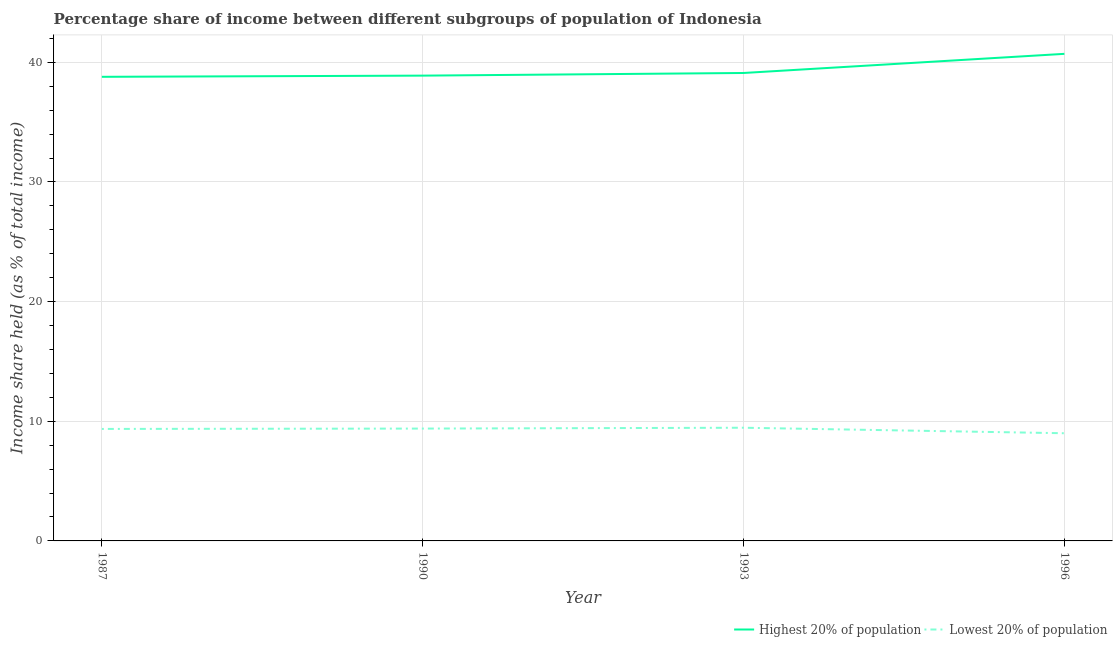How many different coloured lines are there?
Offer a terse response. 2. Does the line corresponding to income share held by lowest 20% of the population intersect with the line corresponding to income share held by highest 20% of the population?
Keep it short and to the point. No. Is the number of lines equal to the number of legend labels?
Your answer should be very brief. Yes. What is the income share held by highest 20% of the population in 1987?
Provide a short and direct response. 38.79. Across all years, what is the maximum income share held by highest 20% of the population?
Provide a succinct answer. 40.71. Across all years, what is the minimum income share held by highest 20% of the population?
Your response must be concise. 38.79. In which year was the income share held by lowest 20% of the population minimum?
Your answer should be very brief. 1996. What is the total income share held by lowest 20% of the population in the graph?
Your answer should be compact. 37.21. What is the difference between the income share held by lowest 20% of the population in 1987 and that in 1990?
Ensure brevity in your answer.  -0.03. What is the difference between the income share held by highest 20% of the population in 1996 and the income share held by lowest 20% of the population in 1990?
Ensure brevity in your answer.  31.32. What is the average income share held by highest 20% of the population per year?
Provide a short and direct response. 39.38. In the year 1993, what is the difference between the income share held by lowest 20% of the population and income share held by highest 20% of the population?
Offer a terse response. -29.65. What is the ratio of the income share held by highest 20% of the population in 1987 to that in 1996?
Provide a succinct answer. 0.95. Is the income share held by highest 20% of the population in 1990 less than that in 1993?
Provide a succinct answer. Yes. Is the difference between the income share held by lowest 20% of the population in 1987 and 1996 greater than the difference between the income share held by highest 20% of the population in 1987 and 1996?
Your answer should be compact. Yes. What is the difference between the highest and the second highest income share held by lowest 20% of the population?
Your answer should be very brief. 0.07. What is the difference between the highest and the lowest income share held by lowest 20% of the population?
Your answer should be compact. 0.46. In how many years, is the income share held by lowest 20% of the population greater than the average income share held by lowest 20% of the population taken over all years?
Ensure brevity in your answer.  3. Is the income share held by highest 20% of the population strictly less than the income share held by lowest 20% of the population over the years?
Make the answer very short. No. How many lines are there?
Your response must be concise. 2. How many years are there in the graph?
Offer a very short reply. 4. Are the values on the major ticks of Y-axis written in scientific E-notation?
Make the answer very short. No. Does the graph contain any zero values?
Offer a very short reply. No. Where does the legend appear in the graph?
Ensure brevity in your answer.  Bottom right. What is the title of the graph?
Provide a short and direct response. Percentage share of income between different subgroups of population of Indonesia. Does "Investment" appear as one of the legend labels in the graph?
Provide a succinct answer. No. What is the label or title of the X-axis?
Keep it short and to the point. Year. What is the label or title of the Y-axis?
Your answer should be very brief. Income share held (as % of total income). What is the Income share held (as % of total income) of Highest 20% of population in 1987?
Your answer should be compact. 38.79. What is the Income share held (as % of total income) in Lowest 20% of population in 1987?
Offer a very short reply. 9.36. What is the Income share held (as % of total income) of Highest 20% of population in 1990?
Your answer should be very brief. 38.89. What is the Income share held (as % of total income) of Lowest 20% of population in 1990?
Offer a very short reply. 9.39. What is the Income share held (as % of total income) of Highest 20% of population in 1993?
Provide a succinct answer. 39.11. What is the Income share held (as % of total income) in Lowest 20% of population in 1993?
Offer a terse response. 9.46. What is the Income share held (as % of total income) in Highest 20% of population in 1996?
Provide a succinct answer. 40.71. Across all years, what is the maximum Income share held (as % of total income) of Highest 20% of population?
Your answer should be compact. 40.71. Across all years, what is the maximum Income share held (as % of total income) in Lowest 20% of population?
Provide a short and direct response. 9.46. Across all years, what is the minimum Income share held (as % of total income) in Highest 20% of population?
Your answer should be very brief. 38.79. What is the total Income share held (as % of total income) in Highest 20% of population in the graph?
Make the answer very short. 157.5. What is the total Income share held (as % of total income) of Lowest 20% of population in the graph?
Offer a very short reply. 37.21. What is the difference between the Income share held (as % of total income) of Highest 20% of population in 1987 and that in 1990?
Keep it short and to the point. -0.1. What is the difference between the Income share held (as % of total income) of Lowest 20% of population in 1987 and that in 1990?
Make the answer very short. -0.03. What is the difference between the Income share held (as % of total income) of Highest 20% of population in 1987 and that in 1993?
Provide a short and direct response. -0.32. What is the difference between the Income share held (as % of total income) in Lowest 20% of population in 1987 and that in 1993?
Give a very brief answer. -0.1. What is the difference between the Income share held (as % of total income) of Highest 20% of population in 1987 and that in 1996?
Offer a terse response. -1.92. What is the difference between the Income share held (as % of total income) of Lowest 20% of population in 1987 and that in 1996?
Make the answer very short. 0.36. What is the difference between the Income share held (as % of total income) in Highest 20% of population in 1990 and that in 1993?
Keep it short and to the point. -0.22. What is the difference between the Income share held (as % of total income) in Lowest 20% of population in 1990 and that in 1993?
Provide a short and direct response. -0.07. What is the difference between the Income share held (as % of total income) in Highest 20% of population in 1990 and that in 1996?
Your answer should be compact. -1.82. What is the difference between the Income share held (as % of total income) in Lowest 20% of population in 1990 and that in 1996?
Give a very brief answer. 0.39. What is the difference between the Income share held (as % of total income) in Highest 20% of population in 1993 and that in 1996?
Your response must be concise. -1.6. What is the difference between the Income share held (as % of total income) in Lowest 20% of population in 1993 and that in 1996?
Your answer should be very brief. 0.46. What is the difference between the Income share held (as % of total income) of Highest 20% of population in 1987 and the Income share held (as % of total income) of Lowest 20% of population in 1990?
Offer a very short reply. 29.4. What is the difference between the Income share held (as % of total income) of Highest 20% of population in 1987 and the Income share held (as % of total income) of Lowest 20% of population in 1993?
Ensure brevity in your answer.  29.33. What is the difference between the Income share held (as % of total income) of Highest 20% of population in 1987 and the Income share held (as % of total income) of Lowest 20% of population in 1996?
Keep it short and to the point. 29.79. What is the difference between the Income share held (as % of total income) in Highest 20% of population in 1990 and the Income share held (as % of total income) in Lowest 20% of population in 1993?
Make the answer very short. 29.43. What is the difference between the Income share held (as % of total income) in Highest 20% of population in 1990 and the Income share held (as % of total income) in Lowest 20% of population in 1996?
Give a very brief answer. 29.89. What is the difference between the Income share held (as % of total income) in Highest 20% of population in 1993 and the Income share held (as % of total income) in Lowest 20% of population in 1996?
Ensure brevity in your answer.  30.11. What is the average Income share held (as % of total income) of Highest 20% of population per year?
Offer a very short reply. 39.38. What is the average Income share held (as % of total income) of Lowest 20% of population per year?
Provide a short and direct response. 9.3. In the year 1987, what is the difference between the Income share held (as % of total income) of Highest 20% of population and Income share held (as % of total income) of Lowest 20% of population?
Make the answer very short. 29.43. In the year 1990, what is the difference between the Income share held (as % of total income) of Highest 20% of population and Income share held (as % of total income) of Lowest 20% of population?
Give a very brief answer. 29.5. In the year 1993, what is the difference between the Income share held (as % of total income) in Highest 20% of population and Income share held (as % of total income) in Lowest 20% of population?
Give a very brief answer. 29.65. In the year 1996, what is the difference between the Income share held (as % of total income) in Highest 20% of population and Income share held (as % of total income) in Lowest 20% of population?
Offer a terse response. 31.71. What is the ratio of the Income share held (as % of total income) in Lowest 20% of population in 1987 to that in 1990?
Offer a very short reply. 1. What is the ratio of the Income share held (as % of total income) in Highest 20% of population in 1987 to that in 1996?
Provide a short and direct response. 0.95. What is the ratio of the Income share held (as % of total income) of Highest 20% of population in 1990 to that in 1996?
Your response must be concise. 0.96. What is the ratio of the Income share held (as % of total income) in Lowest 20% of population in 1990 to that in 1996?
Your answer should be compact. 1.04. What is the ratio of the Income share held (as % of total income) of Highest 20% of population in 1993 to that in 1996?
Provide a succinct answer. 0.96. What is the ratio of the Income share held (as % of total income) in Lowest 20% of population in 1993 to that in 1996?
Provide a short and direct response. 1.05. What is the difference between the highest and the second highest Income share held (as % of total income) in Lowest 20% of population?
Keep it short and to the point. 0.07. What is the difference between the highest and the lowest Income share held (as % of total income) in Highest 20% of population?
Provide a succinct answer. 1.92. What is the difference between the highest and the lowest Income share held (as % of total income) of Lowest 20% of population?
Your answer should be compact. 0.46. 